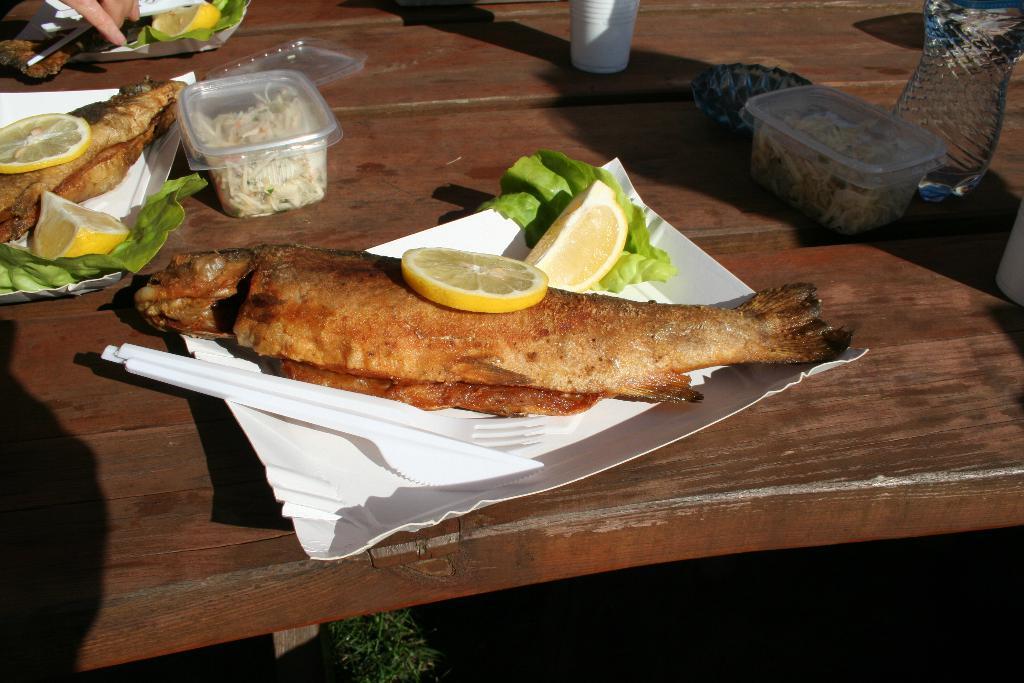Please provide a concise description of this image. In this picture there are few eatables placed in a white paper plates and there are few drinks placed beside it on a brown table. 